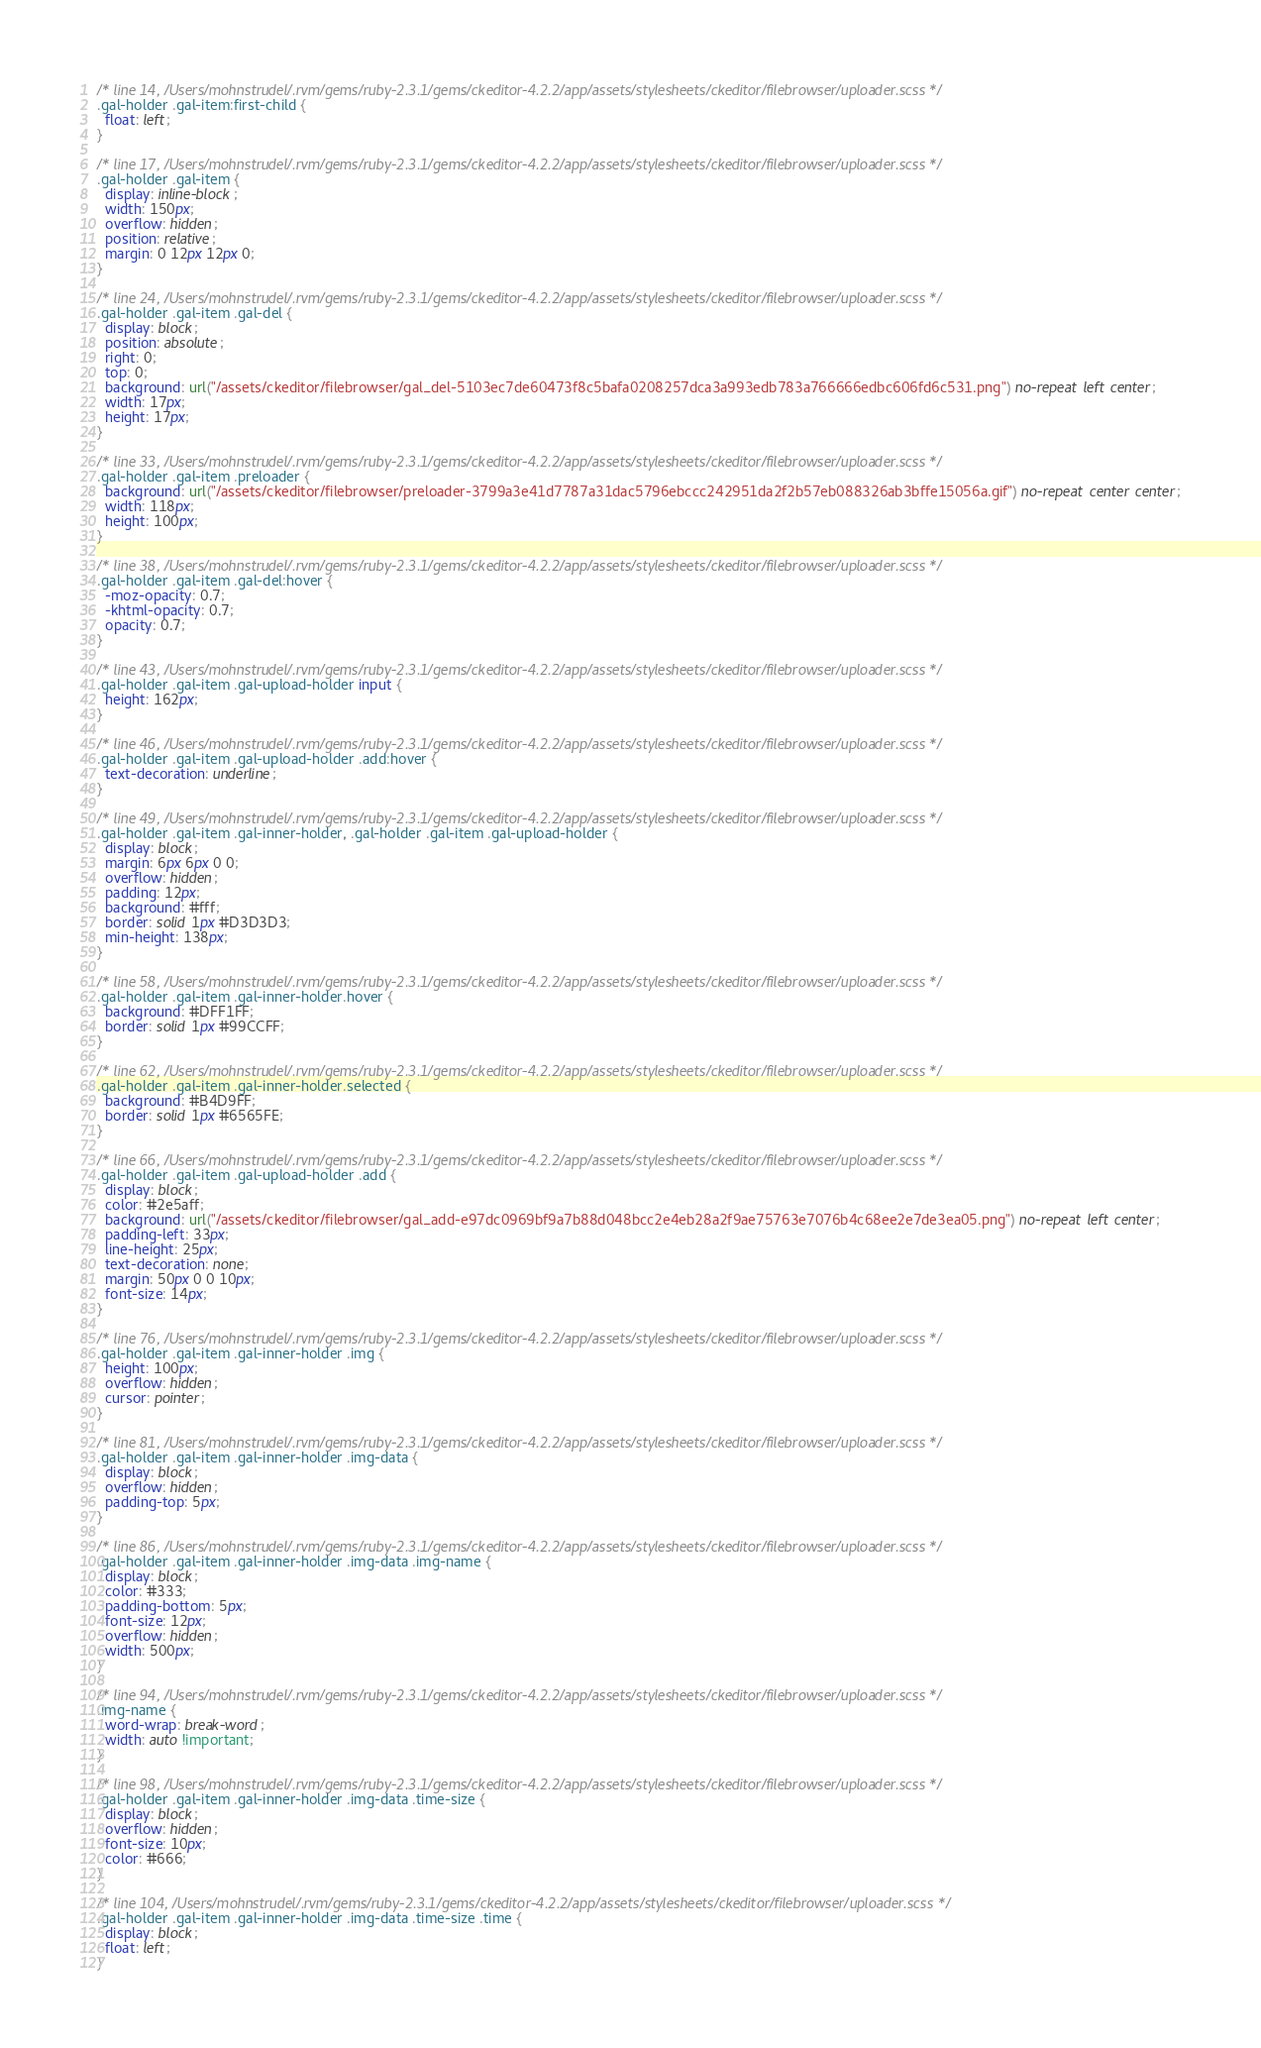<code> <loc_0><loc_0><loc_500><loc_500><_CSS_>
/* line 14, /Users/mohnstrudel/.rvm/gems/ruby-2.3.1/gems/ckeditor-4.2.2/app/assets/stylesheets/ckeditor/filebrowser/uploader.scss */
.gal-holder .gal-item:first-child {
  float: left;
}

/* line 17, /Users/mohnstrudel/.rvm/gems/ruby-2.3.1/gems/ckeditor-4.2.2/app/assets/stylesheets/ckeditor/filebrowser/uploader.scss */
.gal-holder .gal-item {
  display: inline-block;
  width: 150px;
  overflow: hidden;
  position: relative;
  margin: 0 12px 12px 0;
}

/* line 24, /Users/mohnstrudel/.rvm/gems/ruby-2.3.1/gems/ckeditor-4.2.2/app/assets/stylesheets/ckeditor/filebrowser/uploader.scss */
.gal-holder .gal-item .gal-del {
  display: block;
  position: absolute;
  right: 0;
  top: 0;
  background: url("/assets/ckeditor/filebrowser/gal_del-5103ec7de60473f8c5bafa0208257dca3a993edb783a766666edbc606fd6c531.png") no-repeat left center;
  width: 17px;
  height: 17px;
}

/* line 33, /Users/mohnstrudel/.rvm/gems/ruby-2.3.1/gems/ckeditor-4.2.2/app/assets/stylesheets/ckeditor/filebrowser/uploader.scss */
.gal-holder .gal-item .preloader {
  background: url("/assets/ckeditor/filebrowser/preloader-3799a3e41d7787a31dac5796ebccc242951da2f2b57eb088326ab3bffe15056a.gif") no-repeat center center;
  width: 118px;
  height: 100px;
}

/* line 38, /Users/mohnstrudel/.rvm/gems/ruby-2.3.1/gems/ckeditor-4.2.2/app/assets/stylesheets/ckeditor/filebrowser/uploader.scss */
.gal-holder .gal-item .gal-del:hover {
  -moz-opacity: 0.7;
  -khtml-opacity: 0.7;
  opacity: 0.7;
}

/* line 43, /Users/mohnstrudel/.rvm/gems/ruby-2.3.1/gems/ckeditor-4.2.2/app/assets/stylesheets/ckeditor/filebrowser/uploader.scss */
.gal-holder .gal-item .gal-upload-holder input {
  height: 162px;
}

/* line 46, /Users/mohnstrudel/.rvm/gems/ruby-2.3.1/gems/ckeditor-4.2.2/app/assets/stylesheets/ckeditor/filebrowser/uploader.scss */
.gal-holder .gal-item .gal-upload-holder .add:hover {
  text-decoration: underline;
}

/* line 49, /Users/mohnstrudel/.rvm/gems/ruby-2.3.1/gems/ckeditor-4.2.2/app/assets/stylesheets/ckeditor/filebrowser/uploader.scss */
.gal-holder .gal-item .gal-inner-holder, .gal-holder .gal-item .gal-upload-holder {
  display: block;
  margin: 6px 6px 0 0;
  overflow: hidden;
  padding: 12px;
  background: #fff;
  border: solid 1px #D3D3D3;
  min-height: 138px;
}

/* line 58, /Users/mohnstrudel/.rvm/gems/ruby-2.3.1/gems/ckeditor-4.2.2/app/assets/stylesheets/ckeditor/filebrowser/uploader.scss */
.gal-holder .gal-item .gal-inner-holder.hover {
  background: #DFF1FF;
  border: solid 1px #99CCFF;
}

/* line 62, /Users/mohnstrudel/.rvm/gems/ruby-2.3.1/gems/ckeditor-4.2.2/app/assets/stylesheets/ckeditor/filebrowser/uploader.scss */
.gal-holder .gal-item .gal-inner-holder.selected {
  background: #B4D9FF;
  border: solid 1px #6565FE;
}

/* line 66, /Users/mohnstrudel/.rvm/gems/ruby-2.3.1/gems/ckeditor-4.2.2/app/assets/stylesheets/ckeditor/filebrowser/uploader.scss */
.gal-holder .gal-item .gal-upload-holder .add {
  display: block;
  color: #2e5aff;
  background: url("/assets/ckeditor/filebrowser/gal_add-e97dc0969bf9a7b88d048bcc2e4eb28a2f9ae75763e7076b4c68ee2e7de3ea05.png") no-repeat left center;
  padding-left: 33px;
  line-height: 25px;
  text-decoration: none;
  margin: 50px 0 0 10px;
  font-size: 14px;
}

/* line 76, /Users/mohnstrudel/.rvm/gems/ruby-2.3.1/gems/ckeditor-4.2.2/app/assets/stylesheets/ckeditor/filebrowser/uploader.scss */
.gal-holder .gal-item .gal-inner-holder .img {
  height: 100px;
  overflow: hidden;
  cursor: pointer;
}

/* line 81, /Users/mohnstrudel/.rvm/gems/ruby-2.3.1/gems/ckeditor-4.2.2/app/assets/stylesheets/ckeditor/filebrowser/uploader.scss */
.gal-holder .gal-item .gal-inner-holder .img-data {
  display: block;
  overflow: hidden;
  padding-top: 5px;
}

/* line 86, /Users/mohnstrudel/.rvm/gems/ruby-2.3.1/gems/ckeditor-4.2.2/app/assets/stylesheets/ckeditor/filebrowser/uploader.scss */
.gal-holder .gal-item .gal-inner-holder .img-data .img-name {
  display: block;
  color: #333;
  padding-bottom: 5px;
  font-size: 12px;
  overflow: hidden;
  width: 500px;
}

/* line 94, /Users/mohnstrudel/.rvm/gems/ruby-2.3.1/gems/ckeditor-4.2.2/app/assets/stylesheets/ckeditor/filebrowser/uploader.scss */
.img-name {
  word-wrap: break-word;
  width: auto !important;
}

/* line 98, /Users/mohnstrudel/.rvm/gems/ruby-2.3.1/gems/ckeditor-4.2.2/app/assets/stylesheets/ckeditor/filebrowser/uploader.scss */
.gal-holder .gal-item .gal-inner-holder .img-data .time-size {
  display: block;
  overflow: hidden;
  font-size: 10px;
  color: #666;
}

/* line 104, /Users/mohnstrudel/.rvm/gems/ruby-2.3.1/gems/ckeditor-4.2.2/app/assets/stylesheets/ckeditor/filebrowser/uploader.scss */
.gal-holder .gal-item .gal-inner-holder .img-data .time-size .time {
  display: block;
  float: left;
}
</code> 